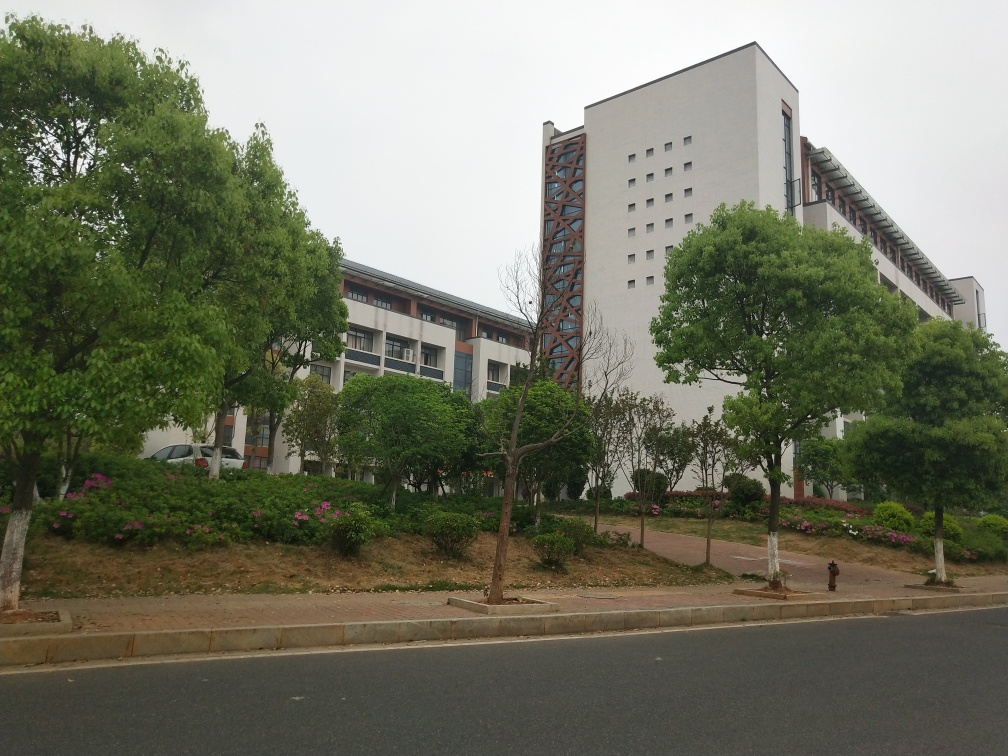Describe the flora present in this image. There's a variety of greenery visible, including several trees with lush foliage, implying it's likely a season of growth. Also, a small landscaped area with what appear to be flowering shrubs adds a touch of color and life to the urban environment. 